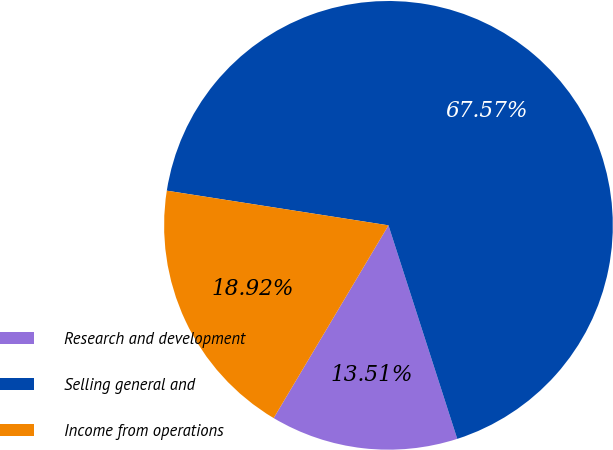Convert chart to OTSL. <chart><loc_0><loc_0><loc_500><loc_500><pie_chart><fcel>Research and development<fcel>Selling general and<fcel>Income from operations<nl><fcel>13.51%<fcel>67.57%<fcel>18.92%<nl></chart> 